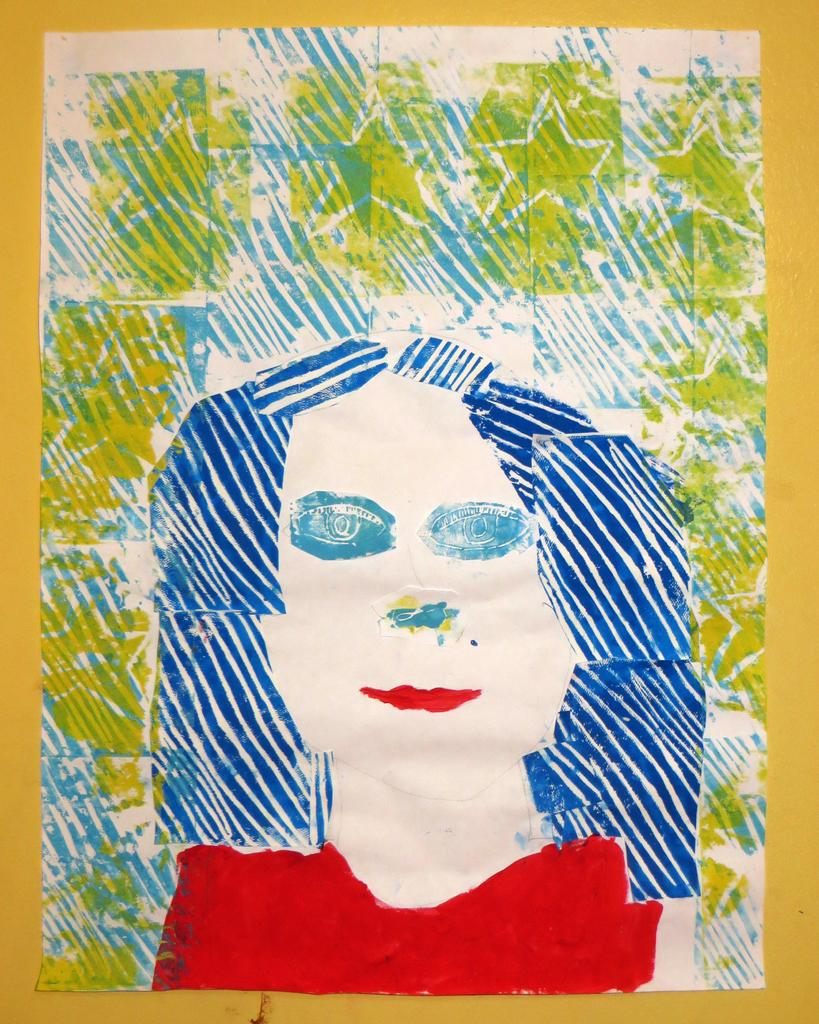What type of artwork is the image? The image is a painting. What is the main subject of the painting? There is a lady depicted in the painting. What type of pickle is the lady holding in the painting? There is no pickle present in the painting; the lady is not holding any object. Can you see any monkeys in the painting? There are no monkeys depicted in the painting. Is there a rainstorm occurring in the painting? There is no indication of a rainstorm in the painting. 